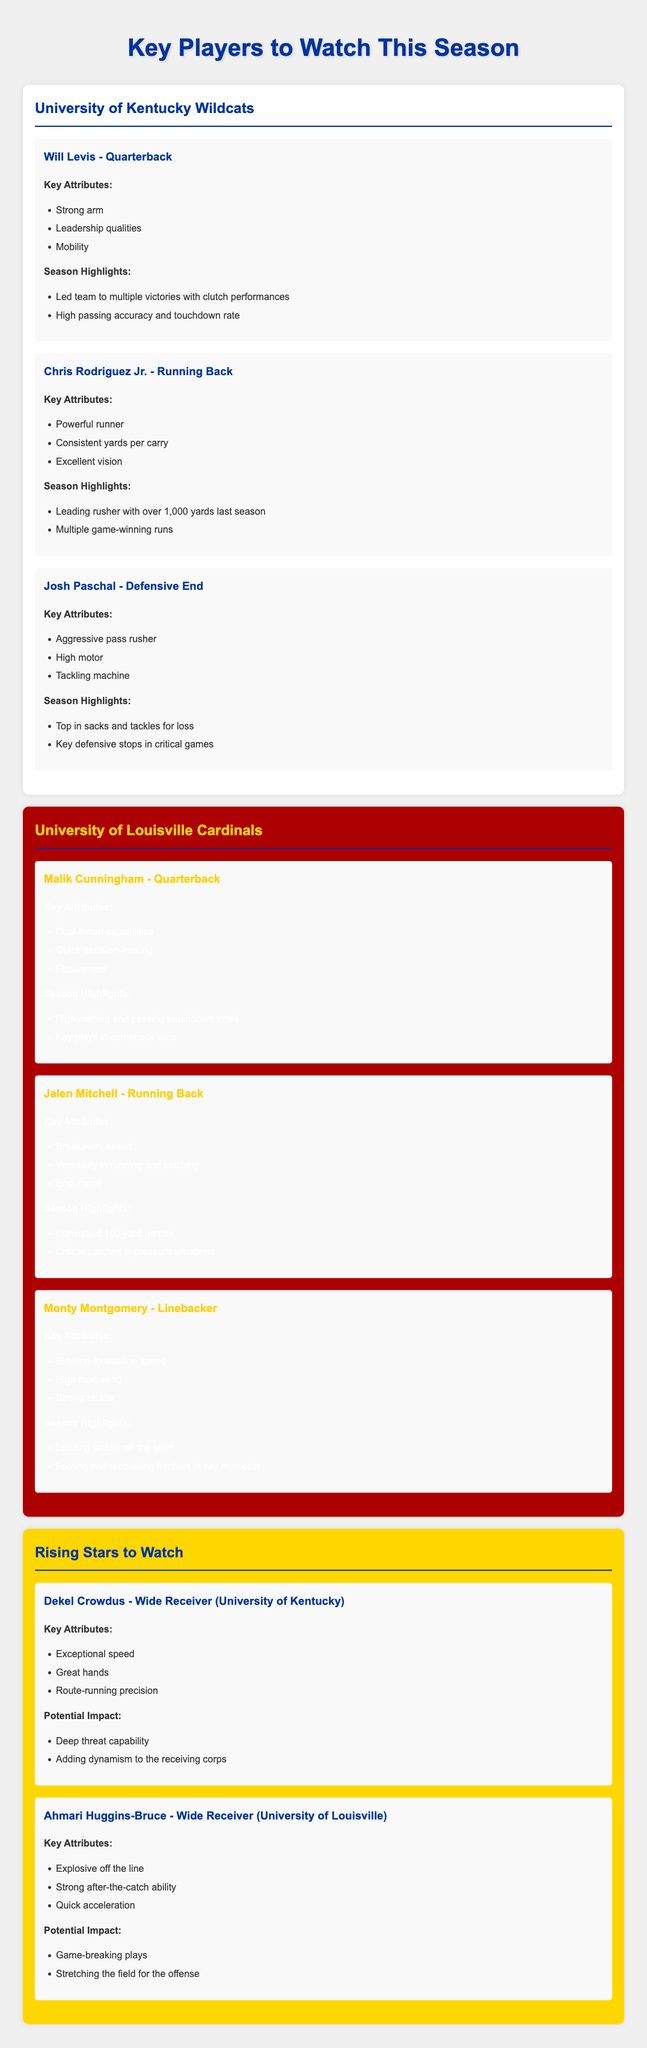What is Will Levis's position? Will Levis is listed as the Quarterback for the University of Kentucky Wildcats.
Answer: Quarterback How many yards did Chris Rodriguez Jr. rush for last season? Chris Rodriguez Jr. is noted to have rushed for over 1,000 yards last season.
Answer: Over 1,000 yards What is Josh Paschal known for? Josh Paschal is recognized for being an aggressive pass rusher and a tackling machine.
Answer: Aggressive pass rusher What key attribute does Malik Cunningham possess? Malik Cunningham has dual-threat capabilities, allowing him to excel as both a passer and a runner.
Answer: Dual-threat capabilities Which team is Monty Montgomery a player for? Monty Montgomery plays for the University of Louisville Cardinals.
Answer: University of Louisville What potential impact does Dekel Crowdus have on his team? Dekel Crowdus is expected to add dynamism to the receiving corps with his deep threat capability.
Answer: Deep threat capability How many critical catches did Jalen Mitchell make under pressure? Jalen Mitchell made critical catches in pressure situations, as highlighted in the document.
Answer: Critical catches What is the background color of the rival team section? The rival team section for the University of Louisville is represented with a background color of red.
Answer: Red Who is listed as a rising star from the University of Louisville? Ahmari Huggins-Bruce is identified as a rising star from the University of Louisville.
Answer: Ahmari Huggins-Bruce 